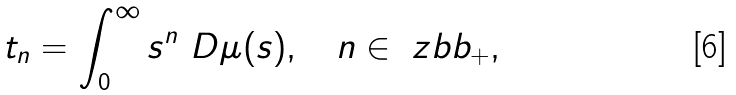<formula> <loc_0><loc_0><loc_500><loc_500>t _ { n } = \int _ { 0 } ^ { \infty } s ^ { n } \ D \mu ( s ) , \quad n \in \ z b b _ { + } ,</formula> 